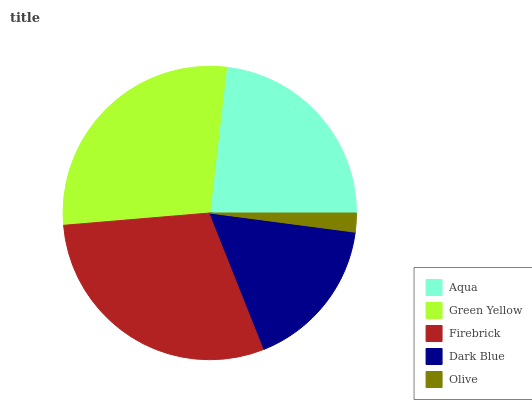Is Olive the minimum?
Answer yes or no. Yes. Is Firebrick the maximum?
Answer yes or no. Yes. Is Green Yellow the minimum?
Answer yes or no. No. Is Green Yellow the maximum?
Answer yes or no. No. Is Green Yellow greater than Aqua?
Answer yes or no. Yes. Is Aqua less than Green Yellow?
Answer yes or no. Yes. Is Aqua greater than Green Yellow?
Answer yes or no. No. Is Green Yellow less than Aqua?
Answer yes or no. No. Is Aqua the high median?
Answer yes or no. Yes. Is Aqua the low median?
Answer yes or no. Yes. Is Dark Blue the high median?
Answer yes or no. No. Is Green Yellow the low median?
Answer yes or no. No. 